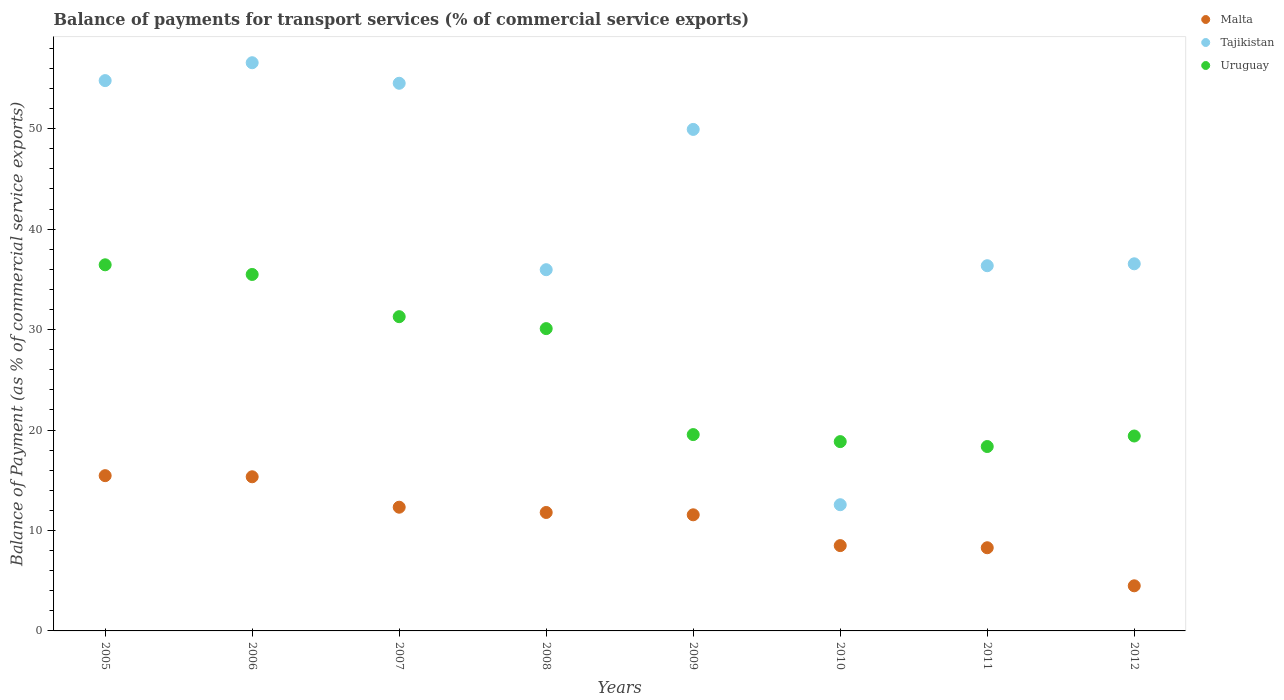How many different coloured dotlines are there?
Your answer should be compact. 3. What is the balance of payments for transport services in Malta in 2007?
Offer a terse response. 12.32. Across all years, what is the maximum balance of payments for transport services in Malta?
Provide a short and direct response. 15.46. Across all years, what is the minimum balance of payments for transport services in Tajikistan?
Your answer should be very brief. 12.57. In which year was the balance of payments for transport services in Tajikistan minimum?
Provide a short and direct response. 2010. What is the total balance of payments for transport services in Tajikistan in the graph?
Your answer should be very brief. 337.27. What is the difference between the balance of payments for transport services in Uruguay in 2005 and that in 2011?
Your response must be concise. 18.09. What is the difference between the balance of payments for transport services in Malta in 2006 and the balance of payments for transport services in Tajikistan in 2005?
Make the answer very short. -39.44. What is the average balance of payments for transport services in Malta per year?
Provide a short and direct response. 10.97. In the year 2006, what is the difference between the balance of payments for transport services in Malta and balance of payments for transport services in Uruguay?
Your answer should be compact. -20.14. What is the ratio of the balance of payments for transport services in Malta in 2010 to that in 2011?
Give a very brief answer. 1.03. Is the difference between the balance of payments for transport services in Malta in 2009 and 2010 greater than the difference between the balance of payments for transport services in Uruguay in 2009 and 2010?
Give a very brief answer. Yes. What is the difference between the highest and the second highest balance of payments for transport services in Uruguay?
Provide a succinct answer. 0.96. What is the difference between the highest and the lowest balance of payments for transport services in Malta?
Your answer should be very brief. 10.97. Is it the case that in every year, the sum of the balance of payments for transport services in Uruguay and balance of payments for transport services in Tajikistan  is greater than the balance of payments for transport services in Malta?
Offer a terse response. Yes. Does the balance of payments for transport services in Uruguay monotonically increase over the years?
Ensure brevity in your answer.  No. Is the balance of payments for transport services in Tajikistan strictly greater than the balance of payments for transport services in Malta over the years?
Offer a terse response. Yes. Is the balance of payments for transport services in Uruguay strictly less than the balance of payments for transport services in Tajikistan over the years?
Offer a very short reply. No. Are the values on the major ticks of Y-axis written in scientific E-notation?
Give a very brief answer. No. How are the legend labels stacked?
Make the answer very short. Vertical. What is the title of the graph?
Ensure brevity in your answer.  Balance of payments for transport services (% of commercial service exports). Does "Egypt, Arab Rep." appear as one of the legend labels in the graph?
Offer a terse response. No. What is the label or title of the Y-axis?
Offer a terse response. Balance of Payment (as % of commercial service exports). What is the Balance of Payment (as % of commercial service exports) in Malta in 2005?
Offer a terse response. 15.46. What is the Balance of Payment (as % of commercial service exports) of Tajikistan in 2005?
Provide a short and direct response. 54.79. What is the Balance of Payment (as % of commercial service exports) in Uruguay in 2005?
Provide a succinct answer. 36.45. What is the Balance of Payment (as % of commercial service exports) in Malta in 2006?
Make the answer very short. 15.35. What is the Balance of Payment (as % of commercial service exports) in Tajikistan in 2006?
Keep it short and to the point. 56.57. What is the Balance of Payment (as % of commercial service exports) of Uruguay in 2006?
Offer a terse response. 35.49. What is the Balance of Payment (as % of commercial service exports) of Malta in 2007?
Provide a short and direct response. 12.32. What is the Balance of Payment (as % of commercial service exports) in Tajikistan in 2007?
Your answer should be very brief. 54.53. What is the Balance of Payment (as % of commercial service exports) of Uruguay in 2007?
Keep it short and to the point. 31.29. What is the Balance of Payment (as % of commercial service exports) in Malta in 2008?
Your answer should be very brief. 11.79. What is the Balance of Payment (as % of commercial service exports) of Tajikistan in 2008?
Provide a short and direct response. 35.96. What is the Balance of Payment (as % of commercial service exports) of Uruguay in 2008?
Your answer should be very brief. 30.1. What is the Balance of Payment (as % of commercial service exports) of Malta in 2009?
Offer a terse response. 11.56. What is the Balance of Payment (as % of commercial service exports) in Tajikistan in 2009?
Offer a terse response. 49.93. What is the Balance of Payment (as % of commercial service exports) of Uruguay in 2009?
Your answer should be compact. 19.55. What is the Balance of Payment (as % of commercial service exports) in Malta in 2010?
Provide a short and direct response. 8.49. What is the Balance of Payment (as % of commercial service exports) in Tajikistan in 2010?
Your response must be concise. 12.57. What is the Balance of Payment (as % of commercial service exports) of Uruguay in 2010?
Provide a short and direct response. 18.85. What is the Balance of Payment (as % of commercial service exports) in Malta in 2011?
Ensure brevity in your answer.  8.28. What is the Balance of Payment (as % of commercial service exports) in Tajikistan in 2011?
Keep it short and to the point. 36.36. What is the Balance of Payment (as % of commercial service exports) in Uruguay in 2011?
Provide a succinct answer. 18.36. What is the Balance of Payment (as % of commercial service exports) in Malta in 2012?
Offer a very short reply. 4.49. What is the Balance of Payment (as % of commercial service exports) of Tajikistan in 2012?
Your answer should be very brief. 36.55. What is the Balance of Payment (as % of commercial service exports) in Uruguay in 2012?
Offer a very short reply. 19.41. Across all years, what is the maximum Balance of Payment (as % of commercial service exports) of Malta?
Your response must be concise. 15.46. Across all years, what is the maximum Balance of Payment (as % of commercial service exports) in Tajikistan?
Give a very brief answer. 56.57. Across all years, what is the maximum Balance of Payment (as % of commercial service exports) in Uruguay?
Your answer should be compact. 36.45. Across all years, what is the minimum Balance of Payment (as % of commercial service exports) in Malta?
Keep it short and to the point. 4.49. Across all years, what is the minimum Balance of Payment (as % of commercial service exports) of Tajikistan?
Your response must be concise. 12.57. Across all years, what is the minimum Balance of Payment (as % of commercial service exports) of Uruguay?
Keep it short and to the point. 18.36. What is the total Balance of Payment (as % of commercial service exports) in Malta in the graph?
Make the answer very short. 87.74. What is the total Balance of Payment (as % of commercial service exports) of Tajikistan in the graph?
Your response must be concise. 337.27. What is the total Balance of Payment (as % of commercial service exports) in Uruguay in the graph?
Offer a terse response. 209.49. What is the difference between the Balance of Payment (as % of commercial service exports) of Malta in 2005 and that in 2006?
Offer a very short reply. 0.11. What is the difference between the Balance of Payment (as % of commercial service exports) in Tajikistan in 2005 and that in 2006?
Provide a succinct answer. -1.78. What is the difference between the Balance of Payment (as % of commercial service exports) of Uruguay in 2005 and that in 2006?
Provide a short and direct response. 0.96. What is the difference between the Balance of Payment (as % of commercial service exports) in Malta in 2005 and that in 2007?
Give a very brief answer. 3.14. What is the difference between the Balance of Payment (as % of commercial service exports) of Tajikistan in 2005 and that in 2007?
Your answer should be compact. 0.27. What is the difference between the Balance of Payment (as % of commercial service exports) of Uruguay in 2005 and that in 2007?
Offer a very short reply. 5.17. What is the difference between the Balance of Payment (as % of commercial service exports) of Malta in 2005 and that in 2008?
Give a very brief answer. 3.67. What is the difference between the Balance of Payment (as % of commercial service exports) of Tajikistan in 2005 and that in 2008?
Keep it short and to the point. 18.83. What is the difference between the Balance of Payment (as % of commercial service exports) in Uruguay in 2005 and that in 2008?
Provide a succinct answer. 6.35. What is the difference between the Balance of Payment (as % of commercial service exports) in Malta in 2005 and that in 2009?
Your answer should be compact. 3.9. What is the difference between the Balance of Payment (as % of commercial service exports) in Tajikistan in 2005 and that in 2009?
Your answer should be very brief. 4.86. What is the difference between the Balance of Payment (as % of commercial service exports) in Uruguay in 2005 and that in 2009?
Offer a terse response. 16.91. What is the difference between the Balance of Payment (as % of commercial service exports) of Malta in 2005 and that in 2010?
Give a very brief answer. 6.96. What is the difference between the Balance of Payment (as % of commercial service exports) in Tajikistan in 2005 and that in 2010?
Ensure brevity in your answer.  42.23. What is the difference between the Balance of Payment (as % of commercial service exports) in Uruguay in 2005 and that in 2010?
Ensure brevity in your answer.  17.61. What is the difference between the Balance of Payment (as % of commercial service exports) of Malta in 2005 and that in 2011?
Make the answer very short. 7.18. What is the difference between the Balance of Payment (as % of commercial service exports) of Tajikistan in 2005 and that in 2011?
Provide a succinct answer. 18.43. What is the difference between the Balance of Payment (as % of commercial service exports) in Uruguay in 2005 and that in 2011?
Provide a short and direct response. 18.09. What is the difference between the Balance of Payment (as % of commercial service exports) of Malta in 2005 and that in 2012?
Offer a very short reply. 10.97. What is the difference between the Balance of Payment (as % of commercial service exports) of Tajikistan in 2005 and that in 2012?
Your answer should be compact. 18.24. What is the difference between the Balance of Payment (as % of commercial service exports) in Uruguay in 2005 and that in 2012?
Provide a short and direct response. 17.05. What is the difference between the Balance of Payment (as % of commercial service exports) in Malta in 2006 and that in 2007?
Your answer should be compact. 3.03. What is the difference between the Balance of Payment (as % of commercial service exports) of Tajikistan in 2006 and that in 2007?
Make the answer very short. 2.05. What is the difference between the Balance of Payment (as % of commercial service exports) of Uruguay in 2006 and that in 2007?
Make the answer very short. 4.2. What is the difference between the Balance of Payment (as % of commercial service exports) in Malta in 2006 and that in 2008?
Provide a succinct answer. 3.55. What is the difference between the Balance of Payment (as % of commercial service exports) in Tajikistan in 2006 and that in 2008?
Your answer should be compact. 20.61. What is the difference between the Balance of Payment (as % of commercial service exports) of Uruguay in 2006 and that in 2008?
Offer a terse response. 5.39. What is the difference between the Balance of Payment (as % of commercial service exports) of Malta in 2006 and that in 2009?
Your response must be concise. 3.79. What is the difference between the Balance of Payment (as % of commercial service exports) in Tajikistan in 2006 and that in 2009?
Your answer should be compact. 6.64. What is the difference between the Balance of Payment (as % of commercial service exports) of Uruguay in 2006 and that in 2009?
Offer a very short reply. 15.94. What is the difference between the Balance of Payment (as % of commercial service exports) of Malta in 2006 and that in 2010?
Provide a short and direct response. 6.85. What is the difference between the Balance of Payment (as % of commercial service exports) in Tajikistan in 2006 and that in 2010?
Your answer should be very brief. 44.01. What is the difference between the Balance of Payment (as % of commercial service exports) in Uruguay in 2006 and that in 2010?
Provide a succinct answer. 16.64. What is the difference between the Balance of Payment (as % of commercial service exports) in Malta in 2006 and that in 2011?
Offer a terse response. 7.07. What is the difference between the Balance of Payment (as % of commercial service exports) of Tajikistan in 2006 and that in 2011?
Offer a terse response. 20.21. What is the difference between the Balance of Payment (as % of commercial service exports) in Uruguay in 2006 and that in 2011?
Ensure brevity in your answer.  17.13. What is the difference between the Balance of Payment (as % of commercial service exports) of Malta in 2006 and that in 2012?
Make the answer very short. 10.86. What is the difference between the Balance of Payment (as % of commercial service exports) in Tajikistan in 2006 and that in 2012?
Make the answer very short. 20.02. What is the difference between the Balance of Payment (as % of commercial service exports) of Uruguay in 2006 and that in 2012?
Ensure brevity in your answer.  16.08. What is the difference between the Balance of Payment (as % of commercial service exports) in Malta in 2007 and that in 2008?
Your response must be concise. 0.52. What is the difference between the Balance of Payment (as % of commercial service exports) of Tajikistan in 2007 and that in 2008?
Provide a succinct answer. 18.56. What is the difference between the Balance of Payment (as % of commercial service exports) of Uruguay in 2007 and that in 2008?
Your answer should be very brief. 1.19. What is the difference between the Balance of Payment (as % of commercial service exports) of Malta in 2007 and that in 2009?
Your answer should be compact. 0.76. What is the difference between the Balance of Payment (as % of commercial service exports) in Tajikistan in 2007 and that in 2009?
Provide a short and direct response. 4.59. What is the difference between the Balance of Payment (as % of commercial service exports) in Uruguay in 2007 and that in 2009?
Offer a very short reply. 11.74. What is the difference between the Balance of Payment (as % of commercial service exports) in Malta in 2007 and that in 2010?
Offer a very short reply. 3.82. What is the difference between the Balance of Payment (as % of commercial service exports) of Tajikistan in 2007 and that in 2010?
Provide a short and direct response. 41.96. What is the difference between the Balance of Payment (as % of commercial service exports) in Uruguay in 2007 and that in 2010?
Your response must be concise. 12.44. What is the difference between the Balance of Payment (as % of commercial service exports) of Malta in 2007 and that in 2011?
Give a very brief answer. 4.04. What is the difference between the Balance of Payment (as % of commercial service exports) in Tajikistan in 2007 and that in 2011?
Provide a succinct answer. 18.16. What is the difference between the Balance of Payment (as % of commercial service exports) of Uruguay in 2007 and that in 2011?
Your response must be concise. 12.93. What is the difference between the Balance of Payment (as % of commercial service exports) of Malta in 2007 and that in 2012?
Keep it short and to the point. 7.83. What is the difference between the Balance of Payment (as % of commercial service exports) in Tajikistan in 2007 and that in 2012?
Provide a short and direct response. 17.97. What is the difference between the Balance of Payment (as % of commercial service exports) in Uruguay in 2007 and that in 2012?
Your answer should be compact. 11.88. What is the difference between the Balance of Payment (as % of commercial service exports) in Malta in 2008 and that in 2009?
Make the answer very short. 0.23. What is the difference between the Balance of Payment (as % of commercial service exports) in Tajikistan in 2008 and that in 2009?
Keep it short and to the point. -13.97. What is the difference between the Balance of Payment (as % of commercial service exports) of Uruguay in 2008 and that in 2009?
Keep it short and to the point. 10.55. What is the difference between the Balance of Payment (as % of commercial service exports) of Malta in 2008 and that in 2010?
Your response must be concise. 3.3. What is the difference between the Balance of Payment (as % of commercial service exports) in Tajikistan in 2008 and that in 2010?
Keep it short and to the point. 23.4. What is the difference between the Balance of Payment (as % of commercial service exports) in Uruguay in 2008 and that in 2010?
Make the answer very short. 11.25. What is the difference between the Balance of Payment (as % of commercial service exports) of Malta in 2008 and that in 2011?
Your answer should be compact. 3.51. What is the difference between the Balance of Payment (as % of commercial service exports) of Tajikistan in 2008 and that in 2011?
Ensure brevity in your answer.  -0.4. What is the difference between the Balance of Payment (as % of commercial service exports) of Uruguay in 2008 and that in 2011?
Give a very brief answer. 11.74. What is the difference between the Balance of Payment (as % of commercial service exports) in Malta in 2008 and that in 2012?
Ensure brevity in your answer.  7.3. What is the difference between the Balance of Payment (as % of commercial service exports) in Tajikistan in 2008 and that in 2012?
Give a very brief answer. -0.59. What is the difference between the Balance of Payment (as % of commercial service exports) in Uruguay in 2008 and that in 2012?
Offer a very short reply. 10.69. What is the difference between the Balance of Payment (as % of commercial service exports) of Malta in 2009 and that in 2010?
Offer a very short reply. 3.07. What is the difference between the Balance of Payment (as % of commercial service exports) of Tajikistan in 2009 and that in 2010?
Give a very brief answer. 37.37. What is the difference between the Balance of Payment (as % of commercial service exports) of Uruguay in 2009 and that in 2010?
Provide a succinct answer. 0.7. What is the difference between the Balance of Payment (as % of commercial service exports) in Malta in 2009 and that in 2011?
Your answer should be compact. 3.28. What is the difference between the Balance of Payment (as % of commercial service exports) of Tajikistan in 2009 and that in 2011?
Your response must be concise. 13.57. What is the difference between the Balance of Payment (as % of commercial service exports) of Uruguay in 2009 and that in 2011?
Give a very brief answer. 1.19. What is the difference between the Balance of Payment (as % of commercial service exports) in Malta in 2009 and that in 2012?
Your answer should be compact. 7.07. What is the difference between the Balance of Payment (as % of commercial service exports) in Tajikistan in 2009 and that in 2012?
Your answer should be very brief. 13.38. What is the difference between the Balance of Payment (as % of commercial service exports) of Uruguay in 2009 and that in 2012?
Provide a succinct answer. 0.14. What is the difference between the Balance of Payment (as % of commercial service exports) in Malta in 2010 and that in 2011?
Provide a succinct answer. 0.21. What is the difference between the Balance of Payment (as % of commercial service exports) of Tajikistan in 2010 and that in 2011?
Your answer should be compact. -23.8. What is the difference between the Balance of Payment (as % of commercial service exports) in Uruguay in 2010 and that in 2011?
Give a very brief answer. 0.49. What is the difference between the Balance of Payment (as % of commercial service exports) in Malta in 2010 and that in 2012?
Your answer should be compact. 4. What is the difference between the Balance of Payment (as % of commercial service exports) in Tajikistan in 2010 and that in 2012?
Ensure brevity in your answer.  -23.99. What is the difference between the Balance of Payment (as % of commercial service exports) of Uruguay in 2010 and that in 2012?
Your answer should be very brief. -0.56. What is the difference between the Balance of Payment (as % of commercial service exports) of Malta in 2011 and that in 2012?
Ensure brevity in your answer.  3.79. What is the difference between the Balance of Payment (as % of commercial service exports) of Tajikistan in 2011 and that in 2012?
Your answer should be compact. -0.19. What is the difference between the Balance of Payment (as % of commercial service exports) of Uruguay in 2011 and that in 2012?
Offer a terse response. -1.05. What is the difference between the Balance of Payment (as % of commercial service exports) of Malta in 2005 and the Balance of Payment (as % of commercial service exports) of Tajikistan in 2006?
Offer a terse response. -41.11. What is the difference between the Balance of Payment (as % of commercial service exports) of Malta in 2005 and the Balance of Payment (as % of commercial service exports) of Uruguay in 2006?
Keep it short and to the point. -20.03. What is the difference between the Balance of Payment (as % of commercial service exports) of Tajikistan in 2005 and the Balance of Payment (as % of commercial service exports) of Uruguay in 2006?
Offer a very short reply. 19.3. What is the difference between the Balance of Payment (as % of commercial service exports) in Malta in 2005 and the Balance of Payment (as % of commercial service exports) in Tajikistan in 2007?
Make the answer very short. -39.07. What is the difference between the Balance of Payment (as % of commercial service exports) of Malta in 2005 and the Balance of Payment (as % of commercial service exports) of Uruguay in 2007?
Your answer should be compact. -15.83. What is the difference between the Balance of Payment (as % of commercial service exports) of Tajikistan in 2005 and the Balance of Payment (as % of commercial service exports) of Uruguay in 2007?
Your answer should be very brief. 23.5. What is the difference between the Balance of Payment (as % of commercial service exports) of Malta in 2005 and the Balance of Payment (as % of commercial service exports) of Tajikistan in 2008?
Provide a short and direct response. -20.51. What is the difference between the Balance of Payment (as % of commercial service exports) in Malta in 2005 and the Balance of Payment (as % of commercial service exports) in Uruguay in 2008?
Make the answer very short. -14.64. What is the difference between the Balance of Payment (as % of commercial service exports) in Tajikistan in 2005 and the Balance of Payment (as % of commercial service exports) in Uruguay in 2008?
Keep it short and to the point. 24.69. What is the difference between the Balance of Payment (as % of commercial service exports) of Malta in 2005 and the Balance of Payment (as % of commercial service exports) of Tajikistan in 2009?
Your answer should be very brief. -34.47. What is the difference between the Balance of Payment (as % of commercial service exports) in Malta in 2005 and the Balance of Payment (as % of commercial service exports) in Uruguay in 2009?
Give a very brief answer. -4.09. What is the difference between the Balance of Payment (as % of commercial service exports) in Tajikistan in 2005 and the Balance of Payment (as % of commercial service exports) in Uruguay in 2009?
Give a very brief answer. 35.25. What is the difference between the Balance of Payment (as % of commercial service exports) in Malta in 2005 and the Balance of Payment (as % of commercial service exports) in Tajikistan in 2010?
Make the answer very short. 2.89. What is the difference between the Balance of Payment (as % of commercial service exports) in Malta in 2005 and the Balance of Payment (as % of commercial service exports) in Uruguay in 2010?
Your answer should be compact. -3.39. What is the difference between the Balance of Payment (as % of commercial service exports) of Tajikistan in 2005 and the Balance of Payment (as % of commercial service exports) of Uruguay in 2010?
Offer a terse response. 35.95. What is the difference between the Balance of Payment (as % of commercial service exports) of Malta in 2005 and the Balance of Payment (as % of commercial service exports) of Tajikistan in 2011?
Ensure brevity in your answer.  -20.9. What is the difference between the Balance of Payment (as % of commercial service exports) in Malta in 2005 and the Balance of Payment (as % of commercial service exports) in Uruguay in 2011?
Keep it short and to the point. -2.9. What is the difference between the Balance of Payment (as % of commercial service exports) of Tajikistan in 2005 and the Balance of Payment (as % of commercial service exports) of Uruguay in 2011?
Your answer should be very brief. 36.43. What is the difference between the Balance of Payment (as % of commercial service exports) in Malta in 2005 and the Balance of Payment (as % of commercial service exports) in Tajikistan in 2012?
Ensure brevity in your answer.  -21.09. What is the difference between the Balance of Payment (as % of commercial service exports) of Malta in 2005 and the Balance of Payment (as % of commercial service exports) of Uruguay in 2012?
Make the answer very short. -3.95. What is the difference between the Balance of Payment (as % of commercial service exports) of Tajikistan in 2005 and the Balance of Payment (as % of commercial service exports) of Uruguay in 2012?
Provide a succinct answer. 35.39. What is the difference between the Balance of Payment (as % of commercial service exports) of Malta in 2006 and the Balance of Payment (as % of commercial service exports) of Tajikistan in 2007?
Your answer should be compact. -39.18. What is the difference between the Balance of Payment (as % of commercial service exports) in Malta in 2006 and the Balance of Payment (as % of commercial service exports) in Uruguay in 2007?
Give a very brief answer. -15.94. What is the difference between the Balance of Payment (as % of commercial service exports) of Tajikistan in 2006 and the Balance of Payment (as % of commercial service exports) of Uruguay in 2007?
Provide a succinct answer. 25.28. What is the difference between the Balance of Payment (as % of commercial service exports) in Malta in 2006 and the Balance of Payment (as % of commercial service exports) in Tajikistan in 2008?
Provide a short and direct response. -20.62. What is the difference between the Balance of Payment (as % of commercial service exports) of Malta in 2006 and the Balance of Payment (as % of commercial service exports) of Uruguay in 2008?
Give a very brief answer. -14.75. What is the difference between the Balance of Payment (as % of commercial service exports) of Tajikistan in 2006 and the Balance of Payment (as % of commercial service exports) of Uruguay in 2008?
Your response must be concise. 26.47. What is the difference between the Balance of Payment (as % of commercial service exports) in Malta in 2006 and the Balance of Payment (as % of commercial service exports) in Tajikistan in 2009?
Offer a very short reply. -34.58. What is the difference between the Balance of Payment (as % of commercial service exports) of Malta in 2006 and the Balance of Payment (as % of commercial service exports) of Uruguay in 2009?
Make the answer very short. -4.2. What is the difference between the Balance of Payment (as % of commercial service exports) in Tajikistan in 2006 and the Balance of Payment (as % of commercial service exports) in Uruguay in 2009?
Ensure brevity in your answer.  37.02. What is the difference between the Balance of Payment (as % of commercial service exports) in Malta in 2006 and the Balance of Payment (as % of commercial service exports) in Tajikistan in 2010?
Offer a terse response. 2.78. What is the difference between the Balance of Payment (as % of commercial service exports) of Malta in 2006 and the Balance of Payment (as % of commercial service exports) of Uruguay in 2010?
Give a very brief answer. -3.5. What is the difference between the Balance of Payment (as % of commercial service exports) in Tajikistan in 2006 and the Balance of Payment (as % of commercial service exports) in Uruguay in 2010?
Provide a succinct answer. 37.72. What is the difference between the Balance of Payment (as % of commercial service exports) in Malta in 2006 and the Balance of Payment (as % of commercial service exports) in Tajikistan in 2011?
Provide a short and direct response. -21.01. What is the difference between the Balance of Payment (as % of commercial service exports) of Malta in 2006 and the Balance of Payment (as % of commercial service exports) of Uruguay in 2011?
Your answer should be very brief. -3.01. What is the difference between the Balance of Payment (as % of commercial service exports) of Tajikistan in 2006 and the Balance of Payment (as % of commercial service exports) of Uruguay in 2011?
Give a very brief answer. 38.21. What is the difference between the Balance of Payment (as % of commercial service exports) of Malta in 2006 and the Balance of Payment (as % of commercial service exports) of Tajikistan in 2012?
Your response must be concise. -21.2. What is the difference between the Balance of Payment (as % of commercial service exports) in Malta in 2006 and the Balance of Payment (as % of commercial service exports) in Uruguay in 2012?
Make the answer very short. -4.06. What is the difference between the Balance of Payment (as % of commercial service exports) of Tajikistan in 2006 and the Balance of Payment (as % of commercial service exports) of Uruguay in 2012?
Make the answer very short. 37.17. What is the difference between the Balance of Payment (as % of commercial service exports) of Malta in 2007 and the Balance of Payment (as % of commercial service exports) of Tajikistan in 2008?
Make the answer very short. -23.65. What is the difference between the Balance of Payment (as % of commercial service exports) in Malta in 2007 and the Balance of Payment (as % of commercial service exports) in Uruguay in 2008?
Your answer should be compact. -17.78. What is the difference between the Balance of Payment (as % of commercial service exports) of Tajikistan in 2007 and the Balance of Payment (as % of commercial service exports) of Uruguay in 2008?
Keep it short and to the point. 24.43. What is the difference between the Balance of Payment (as % of commercial service exports) in Malta in 2007 and the Balance of Payment (as % of commercial service exports) in Tajikistan in 2009?
Keep it short and to the point. -37.62. What is the difference between the Balance of Payment (as % of commercial service exports) of Malta in 2007 and the Balance of Payment (as % of commercial service exports) of Uruguay in 2009?
Offer a terse response. -7.23. What is the difference between the Balance of Payment (as % of commercial service exports) of Tajikistan in 2007 and the Balance of Payment (as % of commercial service exports) of Uruguay in 2009?
Your answer should be very brief. 34.98. What is the difference between the Balance of Payment (as % of commercial service exports) in Malta in 2007 and the Balance of Payment (as % of commercial service exports) in Tajikistan in 2010?
Your response must be concise. -0.25. What is the difference between the Balance of Payment (as % of commercial service exports) in Malta in 2007 and the Balance of Payment (as % of commercial service exports) in Uruguay in 2010?
Your response must be concise. -6.53. What is the difference between the Balance of Payment (as % of commercial service exports) in Tajikistan in 2007 and the Balance of Payment (as % of commercial service exports) in Uruguay in 2010?
Keep it short and to the point. 35.68. What is the difference between the Balance of Payment (as % of commercial service exports) in Malta in 2007 and the Balance of Payment (as % of commercial service exports) in Tajikistan in 2011?
Provide a short and direct response. -24.04. What is the difference between the Balance of Payment (as % of commercial service exports) of Malta in 2007 and the Balance of Payment (as % of commercial service exports) of Uruguay in 2011?
Keep it short and to the point. -6.04. What is the difference between the Balance of Payment (as % of commercial service exports) of Tajikistan in 2007 and the Balance of Payment (as % of commercial service exports) of Uruguay in 2011?
Your answer should be very brief. 36.17. What is the difference between the Balance of Payment (as % of commercial service exports) in Malta in 2007 and the Balance of Payment (as % of commercial service exports) in Tajikistan in 2012?
Your answer should be compact. -24.24. What is the difference between the Balance of Payment (as % of commercial service exports) in Malta in 2007 and the Balance of Payment (as % of commercial service exports) in Uruguay in 2012?
Your answer should be compact. -7.09. What is the difference between the Balance of Payment (as % of commercial service exports) of Tajikistan in 2007 and the Balance of Payment (as % of commercial service exports) of Uruguay in 2012?
Your response must be concise. 35.12. What is the difference between the Balance of Payment (as % of commercial service exports) in Malta in 2008 and the Balance of Payment (as % of commercial service exports) in Tajikistan in 2009?
Ensure brevity in your answer.  -38.14. What is the difference between the Balance of Payment (as % of commercial service exports) of Malta in 2008 and the Balance of Payment (as % of commercial service exports) of Uruguay in 2009?
Your answer should be very brief. -7.75. What is the difference between the Balance of Payment (as % of commercial service exports) of Tajikistan in 2008 and the Balance of Payment (as % of commercial service exports) of Uruguay in 2009?
Keep it short and to the point. 16.42. What is the difference between the Balance of Payment (as % of commercial service exports) in Malta in 2008 and the Balance of Payment (as % of commercial service exports) in Tajikistan in 2010?
Your response must be concise. -0.77. What is the difference between the Balance of Payment (as % of commercial service exports) in Malta in 2008 and the Balance of Payment (as % of commercial service exports) in Uruguay in 2010?
Your response must be concise. -7.05. What is the difference between the Balance of Payment (as % of commercial service exports) in Tajikistan in 2008 and the Balance of Payment (as % of commercial service exports) in Uruguay in 2010?
Offer a terse response. 17.12. What is the difference between the Balance of Payment (as % of commercial service exports) of Malta in 2008 and the Balance of Payment (as % of commercial service exports) of Tajikistan in 2011?
Provide a short and direct response. -24.57. What is the difference between the Balance of Payment (as % of commercial service exports) of Malta in 2008 and the Balance of Payment (as % of commercial service exports) of Uruguay in 2011?
Offer a terse response. -6.57. What is the difference between the Balance of Payment (as % of commercial service exports) in Tajikistan in 2008 and the Balance of Payment (as % of commercial service exports) in Uruguay in 2011?
Your response must be concise. 17.61. What is the difference between the Balance of Payment (as % of commercial service exports) of Malta in 2008 and the Balance of Payment (as % of commercial service exports) of Tajikistan in 2012?
Make the answer very short. -24.76. What is the difference between the Balance of Payment (as % of commercial service exports) in Malta in 2008 and the Balance of Payment (as % of commercial service exports) in Uruguay in 2012?
Give a very brief answer. -7.61. What is the difference between the Balance of Payment (as % of commercial service exports) of Tajikistan in 2008 and the Balance of Payment (as % of commercial service exports) of Uruguay in 2012?
Give a very brief answer. 16.56. What is the difference between the Balance of Payment (as % of commercial service exports) of Malta in 2009 and the Balance of Payment (as % of commercial service exports) of Tajikistan in 2010?
Give a very brief answer. -1. What is the difference between the Balance of Payment (as % of commercial service exports) in Malta in 2009 and the Balance of Payment (as % of commercial service exports) in Uruguay in 2010?
Your response must be concise. -7.29. What is the difference between the Balance of Payment (as % of commercial service exports) of Tajikistan in 2009 and the Balance of Payment (as % of commercial service exports) of Uruguay in 2010?
Your answer should be compact. 31.09. What is the difference between the Balance of Payment (as % of commercial service exports) in Malta in 2009 and the Balance of Payment (as % of commercial service exports) in Tajikistan in 2011?
Make the answer very short. -24.8. What is the difference between the Balance of Payment (as % of commercial service exports) of Malta in 2009 and the Balance of Payment (as % of commercial service exports) of Uruguay in 2011?
Provide a short and direct response. -6.8. What is the difference between the Balance of Payment (as % of commercial service exports) of Tajikistan in 2009 and the Balance of Payment (as % of commercial service exports) of Uruguay in 2011?
Offer a very short reply. 31.57. What is the difference between the Balance of Payment (as % of commercial service exports) of Malta in 2009 and the Balance of Payment (as % of commercial service exports) of Tajikistan in 2012?
Your answer should be very brief. -24.99. What is the difference between the Balance of Payment (as % of commercial service exports) of Malta in 2009 and the Balance of Payment (as % of commercial service exports) of Uruguay in 2012?
Give a very brief answer. -7.85. What is the difference between the Balance of Payment (as % of commercial service exports) in Tajikistan in 2009 and the Balance of Payment (as % of commercial service exports) in Uruguay in 2012?
Your response must be concise. 30.53. What is the difference between the Balance of Payment (as % of commercial service exports) in Malta in 2010 and the Balance of Payment (as % of commercial service exports) in Tajikistan in 2011?
Keep it short and to the point. -27.87. What is the difference between the Balance of Payment (as % of commercial service exports) of Malta in 2010 and the Balance of Payment (as % of commercial service exports) of Uruguay in 2011?
Your answer should be very brief. -9.87. What is the difference between the Balance of Payment (as % of commercial service exports) in Tajikistan in 2010 and the Balance of Payment (as % of commercial service exports) in Uruguay in 2011?
Your answer should be very brief. -5.79. What is the difference between the Balance of Payment (as % of commercial service exports) of Malta in 2010 and the Balance of Payment (as % of commercial service exports) of Tajikistan in 2012?
Your answer should be compact. -28.06. What is the difference between the Balance of Payment (as % of commercial service exports) of Malta in 2010 and the Balance of Payment (as % of commercial service exports) of Uruguay in 2012?
Your answer should be compact. -10.91. What is the difference between the Balance of Payment (as % of commercial service exports) of Tajikistan in 2010 and the Balance of Payment (as % of commercial service exports) of Uruguay in 2012?
Provide a succinct answer. -6.84. What is the difference between the Balance of Payment (as % of commercial service exports) of Malta in 2011 and the Balance of Payment (as % of commercial service exports) of Tajikistan in 2012?
Make the answer very short. -28.27. What is the difference between the Balance of Payment (as % of commercial service exports) of Malta in 2011 and the Balance of Payment (as % of commercial service exports) of Uruguay in 2012?
Offer a very short reply. -11.13. What is the difference between the Balance of Payment (as % of commercial service exports) in Tajikistan in 2011 and the Balance of Payment (as % of commercial service exports) in Uruguay in 2012?
Offer a very short reply. 16.95. What is the average Balance of Payment (as % of commercial service exports) of Malta per year?
Your response must be concise. 10.97. What is the average Balance of Payment (as % of commercial service exports) in Tajikistan per year?
Your answer should be very brief. 42.16. What is the average Balance of Payment (as % of commercial service exports) in Uruguay per year?
Provide a short and direct response. 26.19. In the year 2005, what is the difference between the Balance of Payment (as % of commercial service exports) in Malta and Balance of Payment (as % of commercial service exports) in Tajikistan?
Keep it short and to the point. -39.33. In the year 2005, what is the difference between the Balance of Payment (as % of commercial service exports) of Malta and Balance of Payment (as % of commercial service exports) of Uruguay?
Offer a very short reply. -20.99. In the year 2005, what is the difference between the Balance of Payment (as % of commercial service exports) in Tajikistan and Balance of Payment (as % of commercial service exports) in Uruguay?
Offer a very short reply. 18.34. In the year 2006, what is the difference between the Balance of Payment (as % of commercial service exports) in Malta and Balance of Payment (as % of commercial service exports) in Tajikistan?
Offer a terse response. -41.22. In the year 2006, what is the difference between the Balance of Payment (as % of commercial service exports) in Malta and Balance of Payment (as % of commercial service exports) in Uruguay?
Your answer should be very brief. -20.14. In the year 2006, what is the difference between the Balance of Payment (as % of commercial service exports) in Tajikistan and Balance of Payment (as % of commercial service exports) in Uruguay?
Offer a terse response. 21.08. In the year 2007, what is the difference between the Balance of Payment (as % of commercial service exports) in Malta and Balance of Payment (as % of commercial service exports) in Tajikistan?
Give a very brief answer. -42.21. In the year 2007, what is the difference between the Balance of Payment (as % of commercial service exports) in Malta and Balance of Payment (as % of commercial service exports) in Uruguay?
Keep it short and to the point. -18.97. In the year 2007, what is the difference between the Balance of Payment (as % of commercial service exports) of Tajikistan and Balance of Payment (as % of commercial service exports) of Uruguay?
Your answer should be very brief. 23.24. In the year 2008, what is the difference between the Balance of Payment (as % of commercial service exports) of Malta and Balance of Payment (as % of commercial service exports) of Tajikistan?
Keep it short and to the point. -24.17. In the year 2008, what is the difference between the Balance of Payment (as % of commercial service exports) in Malta and Balance of Payment (as % of commercial service exports) in Uruguay?
Offer a terse response. -18.31. In the year 2008, what is the difference between the Balance of Payment (as % of commercial service exports) in Tajikistan and Balance of Payment (as % of commercial service exports) in Uruguay?
Offer a very short reply. 5.87. In the year 2009, what is the difference between the Balance of Payment (as % of commercial service exports) in Malta and Balance of Payment (as % of commercial service exports) in Tajikistan?
Provide a succinct answer. -38.37. In the year 2009, what is the difference between the Balance of Payment (as % of commercial service exports) of Malta and Balance of Payment (as % of commercial service exports) of Uruguay?
Provide a short and direct response. -7.99. In the year 2009, what is the difference between the Balance of Payment (as % of commercial service exports) in Tajikistan and Balance of Payment (as % of commercial service exports) in Uruguay?
Keep it short and to the point. 30.39. In the year 2010, what is the difference between the Balance of Payment (as % of commercial service exports) in Malta and Balance of Payment (as % of commercial service exports) in Tajikistan?
Ensure brevity in your answer.  -4.07. In the year 2010, what is the difference between the Balance of Payment (as % of commercial service exports) in Malta and Balance of Payment (as % of commercial service exports) in Uruguay?
Your answer should be compact. -10.35. In the year 2010, what is the difference between the Balance of Payment (as % of commercial service exports) of Tajikistan and Balance of Payment (as % of commercial service exports) of Uruguay?
Make the answer very short. -6.28. In the year 2011, what is the difference between the Balance of Payment (as % of commercial service exports) of Malta and Balance of Payment (as % of commercial service exports) of Tajikistan?
Ensure brevity in your answer.  -28.08. In the year 2011, what is the difference between the Balance of Payment (as % of commercial service exports) in Malta and Balance of Payment (as % of commercial service exports) in Uruguay?
Give a very brief answer. -10.08. In the year 2011, what is the difference between the Balance of Payment (as % of commercial service exports) of Tajikistan and Balance of Payment (as % of commercial service exports) of Uruguay?
Make the answer very short. 18. In the year 2012, what is the difference between the Balance of Payment (as % of commercial service exports) in Malta and Balance of Payment (as % of commercial service exports) in Tajikistan?
Your response must be concise. -32.06. In the year 2012, what is the difference between the Balance of Payment (as % of commercial service exports) of Malta and Balance of Payment (as % of commercial service exports) of Uruguay?
Provide a succinct answer. -14.91. In the year 2012, what is the difference between the Balance of Payment (as % of commercial service exports) in Tajikistan and Balance of Payment (as % of commercial service exports) in Uruguay?
Offer a very short reply. 17.15. What is the ratio of the Balance of Payment (as % of commercial service exports) in Malta in 2005 to that in 2006?
Offer a very short reply. 1.01. What is the ratio of the Balance of Payment (as % of commercial service exports) of Tajikistan in 2005 to that in 2006?
Provide a short and direct response. 0.97. What is the ratio of the Balance of Payment (as % of commercial service exports) of Uruguay in 2005 to that in 2006?
Offer a very short reply. 1.03. What is the ratio of the Balance of Payment (as % of commercial service exports) in Malta in 2005 to that in 2007?
Your answer should be very brief. 1.25. What is the ratio of the Balance of Payment (as % of commercial service exports) of Uruguay in 2005 to that in 2007?
Provide a short and direct response. 1.17. What is the ratio of the Balance of Payment (as % of commercial service exports) in Malta in 2005 to that in 2008?
Ensure brevity in your answer.  1.31. What is the ratio of the Balance of Payment (as % of commercial service exports) in Tajikistan in 2005 to that in 2008?
Offer a very short reply. 1.52. What is the ratio of the Balance of Payment (as % of commercial service exports) in Uruguay in 2005 to that in 2008?
Offer a very short reply. 1.21. What is the ratio of the Balance of Payment (as % of commercial service exports) in Malta in 2005 to that in 2009?
Ensure brevity in your answer.  1.34. What is the ratio of the Balance of Payment (as % of commercial service exports) of Tajikistan in 2005 to that in 2009?
Provide a succinct answer. 1.1. What is the ratio of the Balance of Payment (as % of commercial service exports) of Uruguay in 2005 to that in 2009?
Your answer should be compact. 1.86. What is the ratio of the Balance of Payment (as % of commercial service exports) of Malta in 2005 to that in 2010?
Give a very brief answer. 1.82. What is the ratio of the Balance of Payment (as % of commercial service exports) of Tajikistan in 2005 to that in 2010?
Provide a short and direct response. 4.36. What is the ratio of the Balance of Payment (as % of commercial service exports) in Uruguay in 2005 to that in 2010?
Offer a very short reply. 1.93. What is the ratio of the Balance of Payment (as % of commercial service exports) of Malta in 2005 to that in 2011?
Provide a short and direct response. 1.87. What is the ratio of the Balance of Payment (as % of commercial service exports) of Tajikistan in 2005 to that in 2011?
Offer a very short reply. 1.51. What is the ratio of the Balance of Payment (as % of commercial service exports) in Uruguay in 2005 to that in 2011?
Your answer should be compact. 1.99. What is the ratio of the Balance of Payment (as % of commercial service exports) in Malta in 2005 to that in 2012?
Keep it short and to the point. 3.44. What is the ratio of the Balance of Payment (as % of commercial service exports) of Tajikistan in 2005 to that in 2012?
Offer a very short reply. 1.5. What is the ratio of the Balance of Payment (as % of commercial service exports) in Uruguay in 2005 to that in 2012?
Your answer should be very brief. 1.88. What is the ratio of the Balance of Payment (as % of commercial service exports) in Malta in 2006 to that in 2007?
Offer a terse response. 1.25. What is the ratio of the Balance of Payment (as % of commercial service exports) in Tajikistan in 2006 to that in 2007?
Give a very brief answer. 1.04. What is the ratio of the Balance of Payment (as % of commercial service exports) in Uruguay in 2006 to that in 2007?
Your answer should be very brief. 1.13. What is the ratio of the Balance of Payment (as % of commercial service exports) in Malta in 2006 to that in 2008?
Provide a short and direct response. 1.3. What is the ratio of the Balance of Payment (as % of commercial service exports) in Tajikistan in 2006 to that in 2008?
Make the answer very short. 1.57. What is the ratio of the Balance of Payment (as % of commercial service exports) of Uruguay in 2006 to that in 2008?
Keep it short and to the point. 1.18. What is the ratio of the Balance of Payment (as % of commercial service exports) of Malta in 2006 to that in 2009?
Provide a succinct answer. 1.33. What is the ratio of the Balance of Payment (as % of commercial service exports) in Tajikistan in 2006 to that in 2009?
Keep it short and to the point. 1.13. What is the ratio of the Balance of Payment (as % of commercial service exports) of Uruguay in 2006 to that in 2009?
Offer a very short reply. 1.82. What is the ratio of the Balance of Payment (as % of commercial service exports) in Malta in 2006 to that in 2010?
Your answer should be compact. 1.81. What is the ratio of the Balance of Payment (as % of commercial service exports) in Tajikistan in 2006 to that in 2010?
Your response must be concise. 4.5. What is the ratio of the Balance of Payment (as % of commercial service exports) of Uruguay in 2006 to that in 2010?
Your response must be concise. 1.88. What is the ratio of the Balance of Payment (as % of commercial service exports) in Malta in 2006 to that in 2011?
Give a very brief answer. 1.85. What is the ratio of the Balance of Payment (as % of commercial service exports) in Tajikistan in 2006 to that in 2011?
Offer a very short reply. 1.56. What is the ratio of the Balance of Payment (as % of commercial service exports) of Uruguay in 2006 to that in 2011?
Give a very brief answer. 1.93. What is the ratio of the Balance of Payment (as % of commercial service exports) of Malta in 2006 to that in 2012?
Make the answer very short. 3.42. What is the ratio of the Balance of Payment (as % of commercial service exports) in Tajikistan in 2006 to that in 2012?
Provide a succinct answer. 1.55. What is the ratio of the Balance of Payment (as % of commercial service exports) of Uruguay in 2006 to that in 2012?
Make the answer very short. 1.83. What is the ratio of the Balance of Payment (as % of commercial service exports) of Malta in 2007 to that in 2008?
Provide a short and direct response. 1.04. What is the ratio of the Balance of Payment (as % of commercial service exports) in Tajikistan in 2007 to that in 2008?
Your answer should be compact. 1.52. What is the ratio of the Balance of Payment (as % of commercial service exports) in Uruguay in 2007 to that in 2008?
Offer a very short reply. 1.04. What is the ratio of the Balance of Payment (as % of commercial service exports) of Malta in 2007 to that in 2009?
Keep it short and to the point. 1.07. What is the ratio of the Balance of Payment (as % of commercial service exports) of Tajikistan in 2007 to that in 2009?
Keep it short and to the point. 1.09. What is the ratio of the Balance of Payment (as % of commercial service exports) in Uruguay in 2007 to that in 2009?
Offer a very short reply. 1.6. What is the ratio of the Balance of Payment (as % of commercial service exports) of Malta in 2007 to that in 2010?
Keep it short and to the point. 1.45. What is the ratio of the Balance of Payment (as % of commercial service exports) in Tajikistan in 2007 to that in 2010?
Make the answer very short. 4.34. What is the ratio of the Balance of Payment (as % of commercial service exports) of Uruguay in 2007 to that in 2010?
Make the answer very short. 1.66. What is the ratio of the Balance of Payment (as % of commercial service exports) in Malta in 2007 to that in 2011?
Your answer should be very brief. 1.49. What is the ratio of the Balance of Payment (as % of commercial service exports) in Tajikistan in 2007 to that in 2011?
Provide a short and direct response. 1.5. What is the ratio of the Balance of Payment (as % of commercial service exports) of Uruguay in 2007 to that in 2011?
Your response must be concise. 1.7. What is the ratio of the Balance of Payment (as % of commercial service exports) of Malta in 2007 to that in 2012?
Provide a succinct answer. 2.74. What is the ratio of the Balance of Payment (as % of commercial service exports) in Tajikistan in 2007 to that in 2012?
Keep it short and to the point. 1.49. What is the ratio of the Balance of Payment (as % of commercial service exports) of Uruguay in 2007 to that in 2012?
Your answer should be very brief. 1.61. What is the ratio of the Balance of Payment (as % of commercial service exports) of Malta in 2008 to that in 2009?
Offer a terse response. 1.02. What is the ratio of the Balance of Payment (as % of commercial service exports) in Tajikistan in 2008 to that in 2009?
Offer a very short reply. 0.72. What is the ratio of the Balance of Payment (as % of commercial service exports) of Uruguay in 2008 to that in 2009?
Provide a short and direct response. 1.54. What is the ratio of the Balance of Payment (as % of commercial service exports) of Malta in 2008 to that in 2010?
Ensure brevity in your answer.  1.39. What is the ratio of the Balance of Payment (as % of commercial service exports) of Tajikistan in 2008 to that in 2010?
Your response must be concise. 2.86. What is the ratio of the Balance of Payment (as % of commercial service exports) of Uruguay in 2008 to that in 2010?
Your answer should be compact. 1.6. What is the ratio of the Balance of Payment (as % of commercial service exports) of Malta in 2008 to that in 2011?
Your response must be concise. 1.42. What is the ratio of the Balance of Payment (as % of commercial service exports) of Uruguay in 2008 to that in 2011?
Offer a terse response. 1.64. What is the ratio of the Balance of Payment (as % of commercial service exports) of Malta in 2008 to that in 2012?
Offer a terse response. 2.63. What is the ratio of the Balance of Payment (as % of commercial service exports) of Tajikistan in 2008 to that in 2012?
Your answer should be very brief. 0.98. What is the ratio of the Balance of Payment (as % of commercial service exports) in Uruguay in 2008 to that in 2012?
Give a very brief answer. 1.55. What is the ratio of the Balance of Payment (as % of commercial service exports) in Malta in 2009 to that in 2010?
Keep it short and to the point. 1.36. What is the ratio of the Balance of Payment (as % of commercial service exports) in Tajikistan in 2009 to that in 2010?
Your response must be concise. 3.97. What is the ratio of the Balance of Payment (as % of commercial service exports) in Uruguay in 2009 to that in 2010?
Provide a short and direct response. 1.04. What is the ratio of the Balance of Payment (as % of commercial service exports) of Malta in 2009 to that in 2011?
Your response must be concise. 1.4. What is the ratio of the Balance of Payment (as % of commercial service exports) of Tajikistan in 2009 to that in 2011?
Your answer should be very brief. 1.37. What is the ratio of the Balance of Payment (as % of commercial service exports) in Uruguay in 2009 to that in 2011?
Your answer should be very brief. 1.06. What is the ratio of the Balance of Payment (as % of commercial service exports) in Malta in 2009 to that in 2012?
Make the answer very short. 2.57. What is the ratio of the Balance of Payment (as % of commercial service exports) of Tajikistan in 2009 to that in 2012?
Your response must be concise. 1.37. What is the ratio of the Balance of Payment (as % of commercial service exports) of Uruguay in 2009 to that in 2012?
Your answer should be compact. 1.01. What is the ratio of the Balance of Payment (as % of commercial service exports) of Malta in 2010 to that in 2011?
Provide a succinct answer. 1.03. What is the ratio of the Balance of Payment (as % of commercial service exports) of Tajikistan in 2010 to that in 2011?
Offer a terse response. 0.35. What is the ratio of the Balance of Payment (as % of commercial service exports) of Uruguay in 2010 to that in 2011?
Offer a very short reply. 1.03. What is the ratio of the Balance of Payment (as % of commercial service exports) of Malta in 2010 to that in 2012?
Make the answer very short. 1.89. What is the ratio of the Balance of Payment (as % of commercial service exports) in Tajikistan in 2010 to that in 2012?
Offer a very short reply. 0.34. What is the ratio of the Balance of Payment (as % of commercial service exports) in Uruguay in 2010 to that in 2012?
Your answer should be very brief. 0.97. What is the ratio of the Balance of Payment (as % of commercial service exports) of Malta in 2011 to that in 2012?
Make the answer very short. 1.84. What is the ratio of the Balance of Payment (as % of commercial service exports) of Tajikistan in 2011 to that in 2012?
Make the answer very short. 0.99. What is the ratio of the Balance of Payment (as % of commercial service exports) in Uruguay in 2011 to that in 2012?
Your response must be concise. 0.95. What is the difference between the highest and the second highest Balance of Payment (as % of commercial service exports) in Malta?
Keep it short and to the point. 0.11. What is the difference between the highest and the second highest Balance of Payment (as % of commercial service exports) in Tajikistan?
Make the answer very short. 1.78. What is the difference between the highest and the second highest Balance of Payment (as % of commercial service exports) in Uruguay?
Offer a very short reply. 0.96. What is the difference between the highest and the lowest Balance of Payment (as % of commercial service exports) of Malta?
Your answer should be compact. 10.97. What is the difference between the highest and the lowest Balance of Payment (as % of commercial service exports) in Tajikistan?
Provide a succinct answer. 44.01. What is the difference between the highest and the lowest Balance of Payment (as % of commercial service exports) in Uruguay?
Offer a very short reply. 18.09. 